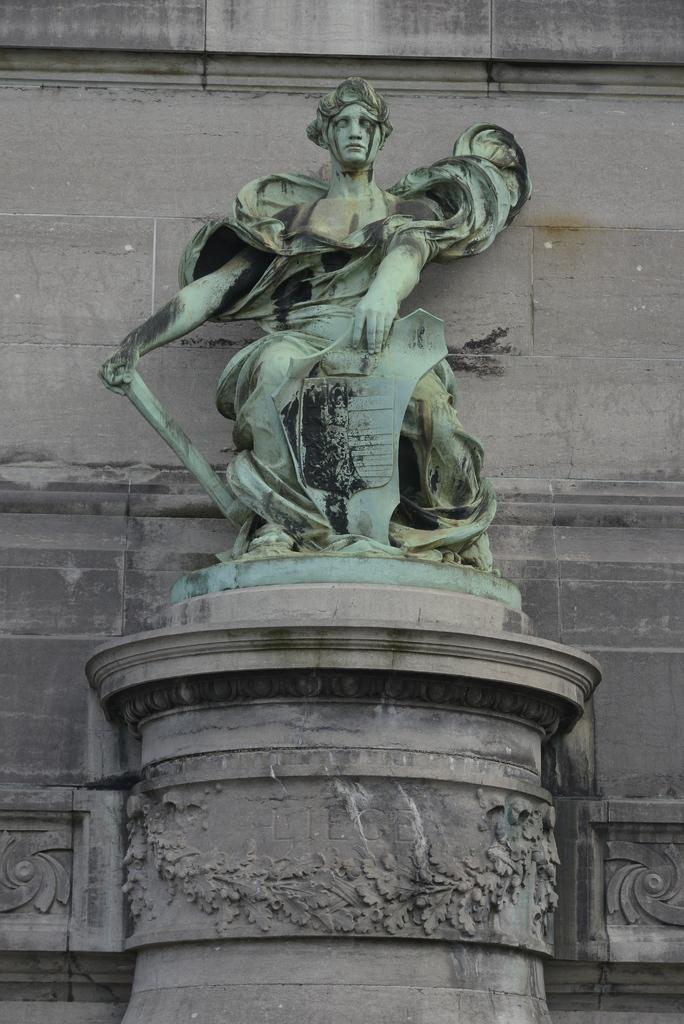What is the main subject of the image? There is a statue in the image. How is the statue positioned in the image? The statue is on a pillar. What is visible behind the statue? There is a wall behind the statue. What type of soup is being served to the children in the image? There are no children or soup present in the image; it features a statue on a pillar with a wall behind it. 